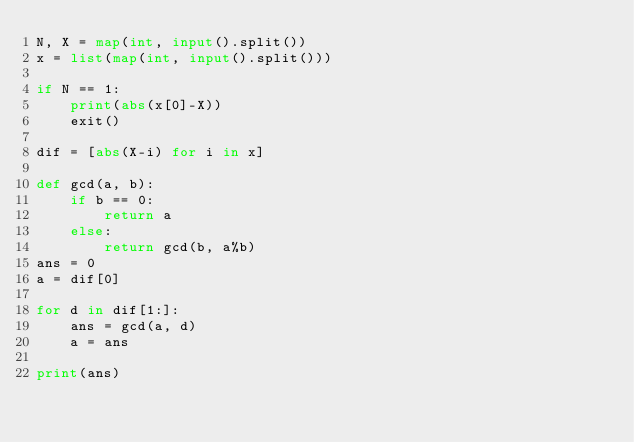<code> <loc_0><loc_0><loc_500><loc_500><_Python_>N, X = map(int, input().split())
x = list(map(int, input().split()))

if N == 1:
    print(abs(x[0]-X))
    exit()

dif = [abs(X-i) for i in x]

def gcd(a, b):
    if b == 0:
        return a
    else:
        return gcd(b, a%b)
ans = 0
a = dif[0]

for d in dif[1:]:
    ans = gcd(a, d)
    a = ans

print(ans)</code> 